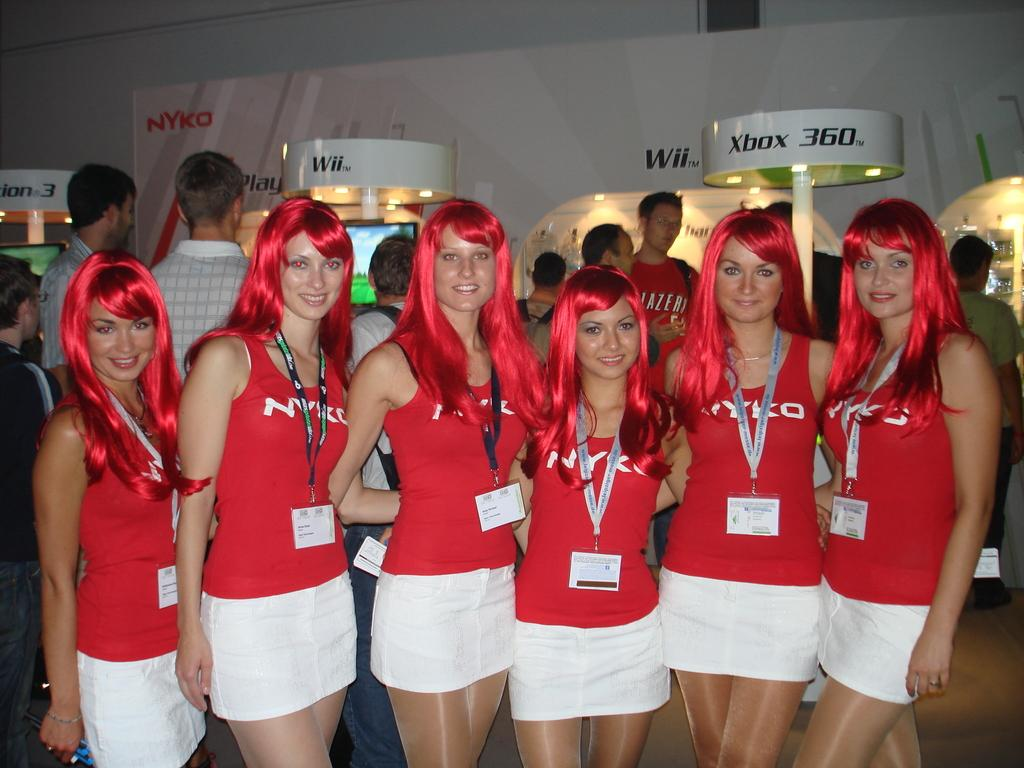What are the people in the image doing? The people in the image are standing on the floor and smiling. Can you describe the background of the image? In the background of the image, there is a banner, lights, poles, monitors, a wall, and other objects. How many people are visible in the image? There are people standing on the floor and visible in the background, but the exact number cannot be determined from the provided facts. What type of nail is being hammered into the fog in the image? There is no nail or fog present in the image. 